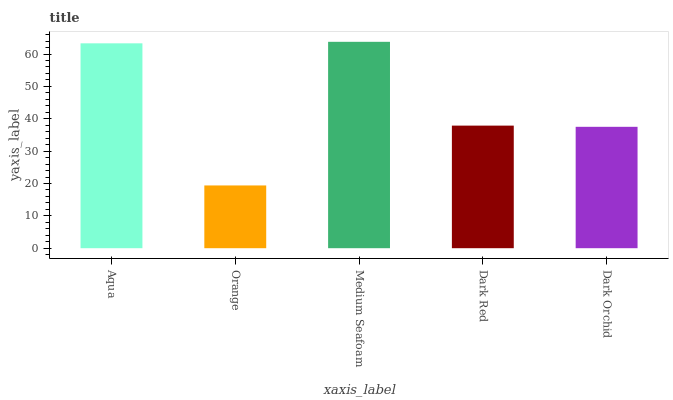Is Medium Seafoam the minimum?
Answer yes or no. No. Is Orange the maximum?
Answer yes or no. No. Is Medium Seafoam greater than Orange?
Answer yes or no. Yes. Is Orange less than Medium Seafoam?
Answer yes or no. Yes. Is Orange greater than Medium Seafoam?
Answer yes or no. No. Is Medium Seafoam less than Orange?
Answer yes or no. No. Is Dark Red the high median?
Answer yes or no. Yes. Is Dark Red the low median?
Answer yes or no. Yes. Is Aqua the high median?
Answer yes or no. No. Is Dark Orchid the low median?
Answer yes or no. No. 